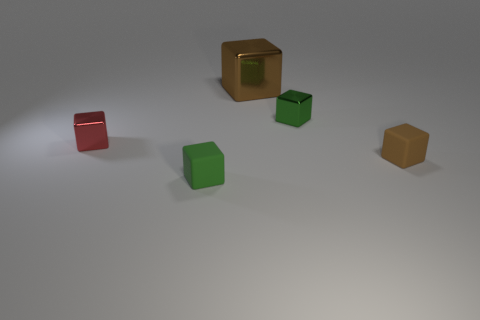Subtract 1 blocks. How many blocks are left? 4 Subtract all brown cubes. How many cubes are left? 3 Subtract all brown matte cubes. How many cubes are left? 4 Subtract all cyan cubes. Subtract all blue spheres. How many cubes are left? 5 Add 3 big red matte objects. How many objects exist? 8 Add 3 brown shiny cylinders. How many brown shiny cylinders exist? 3 Subtract 0 gray balls. How many objects are left? 5 Subtract all green objects. Subtract all small matte cubes. How many objects are left? 1 Add 1 tiny rubber cubes. How many tiny rubber cubes are left? 3 